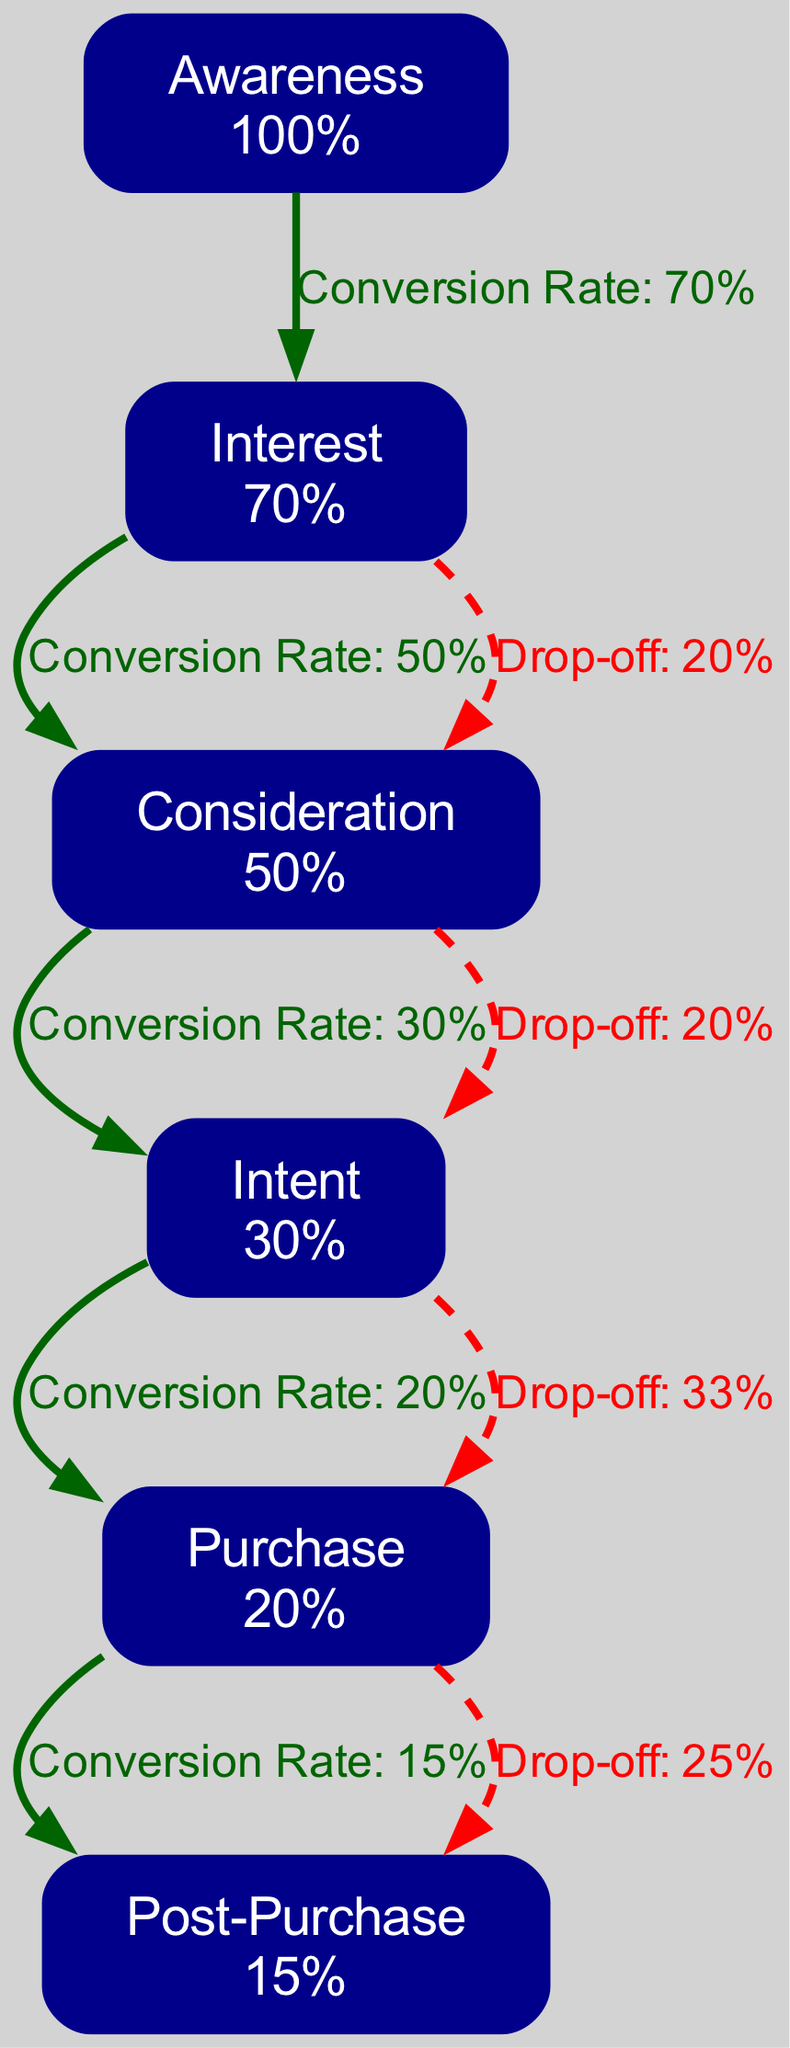What is the conversion rate at the Awareness stage? The diagram indicates that the conversion rate at the Awareness stage is labeled as "100%."
Answer: 100% What is the drop-off rate from Interest to Consideration? According to the drop-off points, the rate from Interest to Consideration is noted as "20%."
Answer: 20% How many stages are depicted in the sales funnel? There are six stages represented: Awareness, Interest, Consideration, Intent, Purchase, and Post-Purchase.
Answer: 6 What is the conversion rate from Intent to Purchase? The conversion rate is specified on the edge leading from Intent to Purchase in the diagram, which is labeled as "20%."
Answer: 20% Which stage has the highest conversion rate? The Awareness stage has the highest conversion rate of "100%."
Answer: Awareness What percentage of customers drops off between Consideration and Intent? The diagram shows a drop-off rate of "20%" between the Consideration and Intent stages.
Answer: 20% What is the conversion rate of the Purchase stage? Based on the nodes in the diagram, the conversion rate for the Purchase stage is listed as "20%."
Answer: 20% Which stage represents the final step in the sales funnel? The final step in the sales funnel is represented by the Purchase stage.
Answer: Purchase What is the drop-off percentage from Intent to Purchase? The edge connecting Intent to Purchase indicates a drop-off rate of "33%."
Answer: 33% How does the conversion rate from Interest to Consideration compare to the rate from Consideration to Intent? The conversion rate from Interest to Consideration is "50%," while from Consideration to Intent it is "30%," indicating a decline.
Answer: Higher 